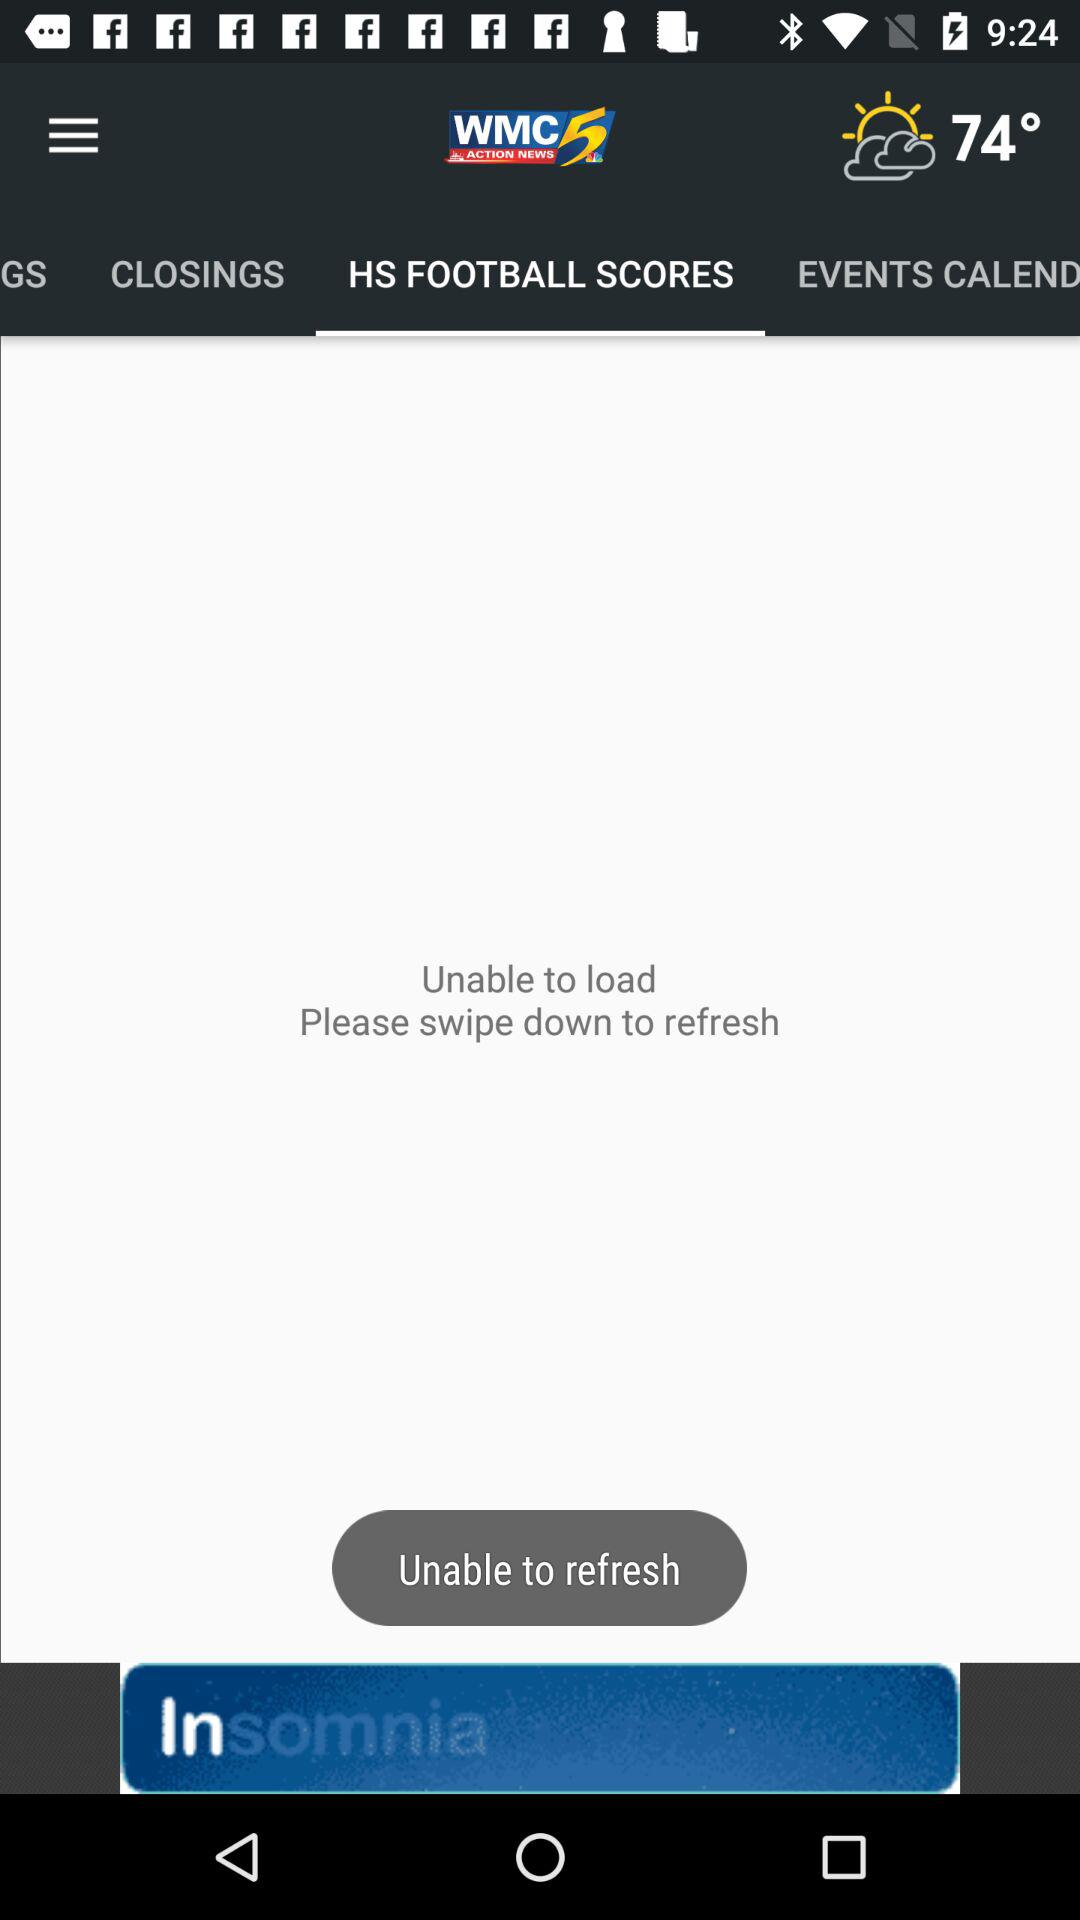What type of weather is showing on the screen?
When the provided information is insufficient, respond with <no answer>. <no answer> 